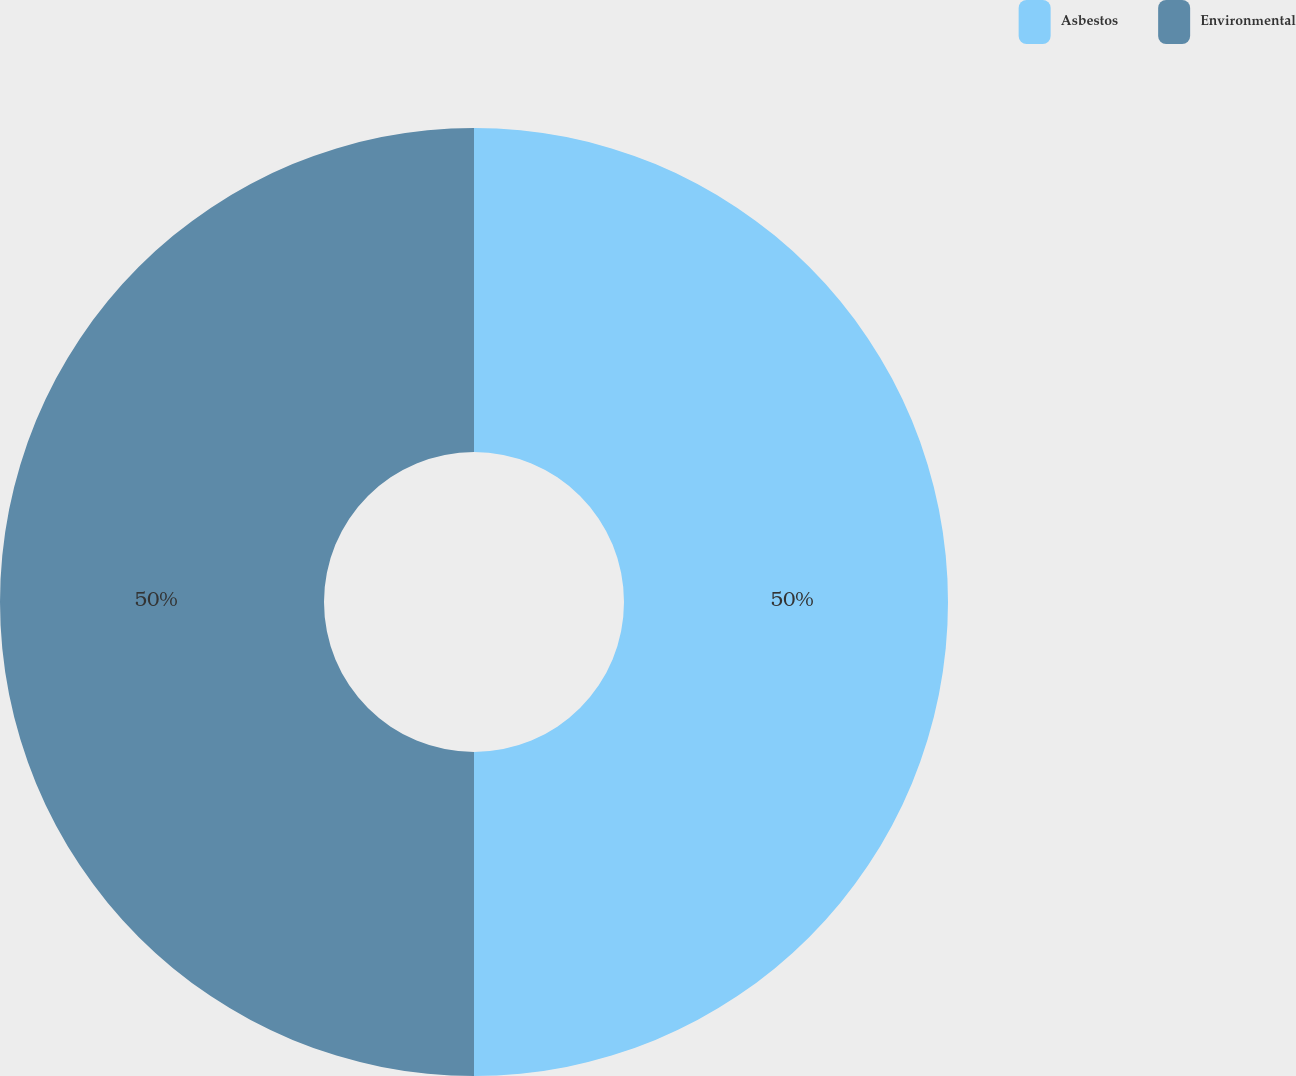<chart> <loc_0><loc_0><loc_500><loc_500><pie_chart><fcel>Asbestos<fcel>Environmental<nl><fcel>50.0%<fcel>50.0%<nl></chart> 